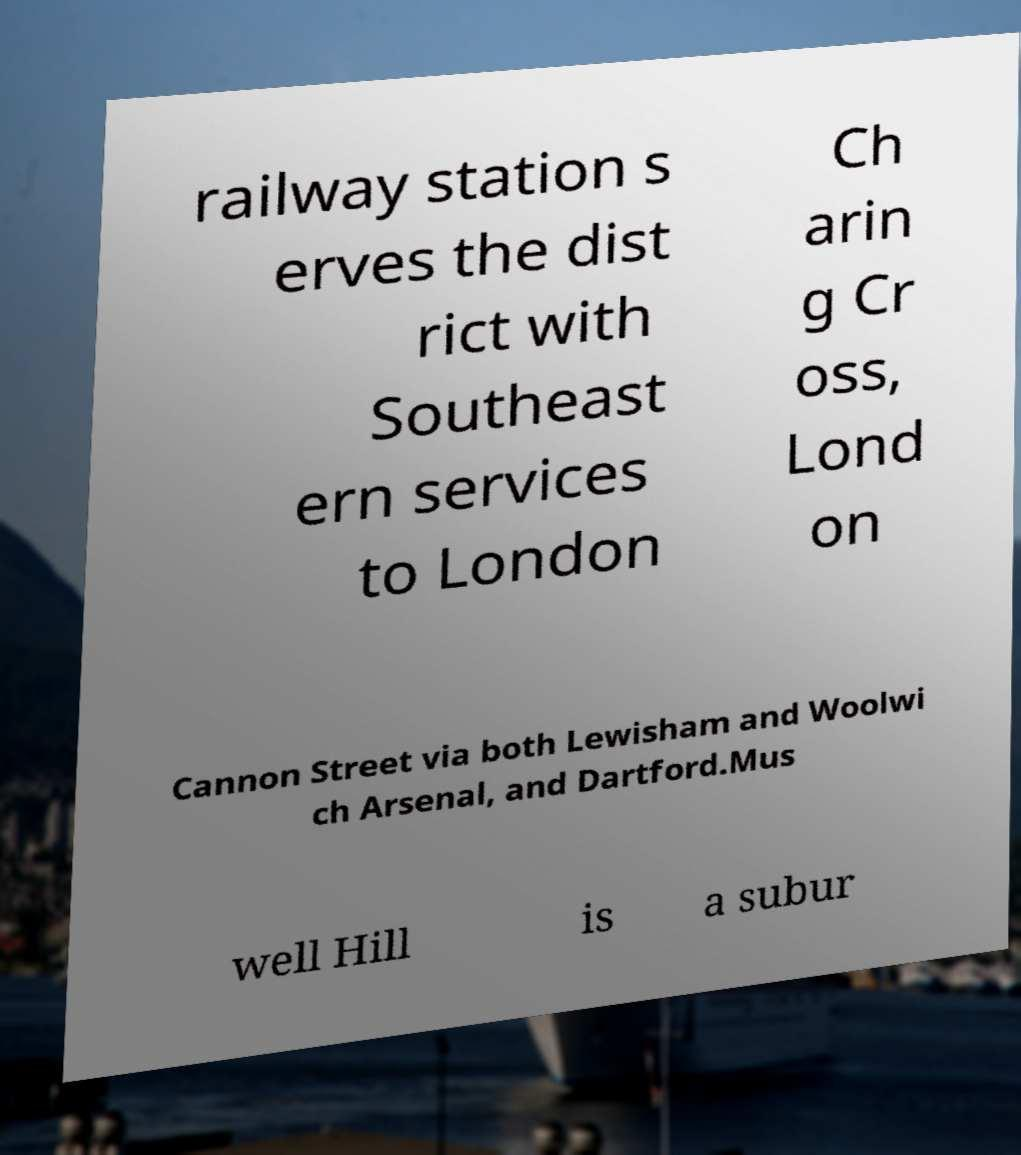Can you read and provide the text displayed in the image?This photo seems to have some interesting text. Can you extract and type it out for me? railway station s erves the dist rict with Southeast ern services to London Ch arin g Cr oss, Lond on Cannon Street via both Lewisham and Woolwi ch Arsenal, and Dartford.Mus well Hill is a subur 